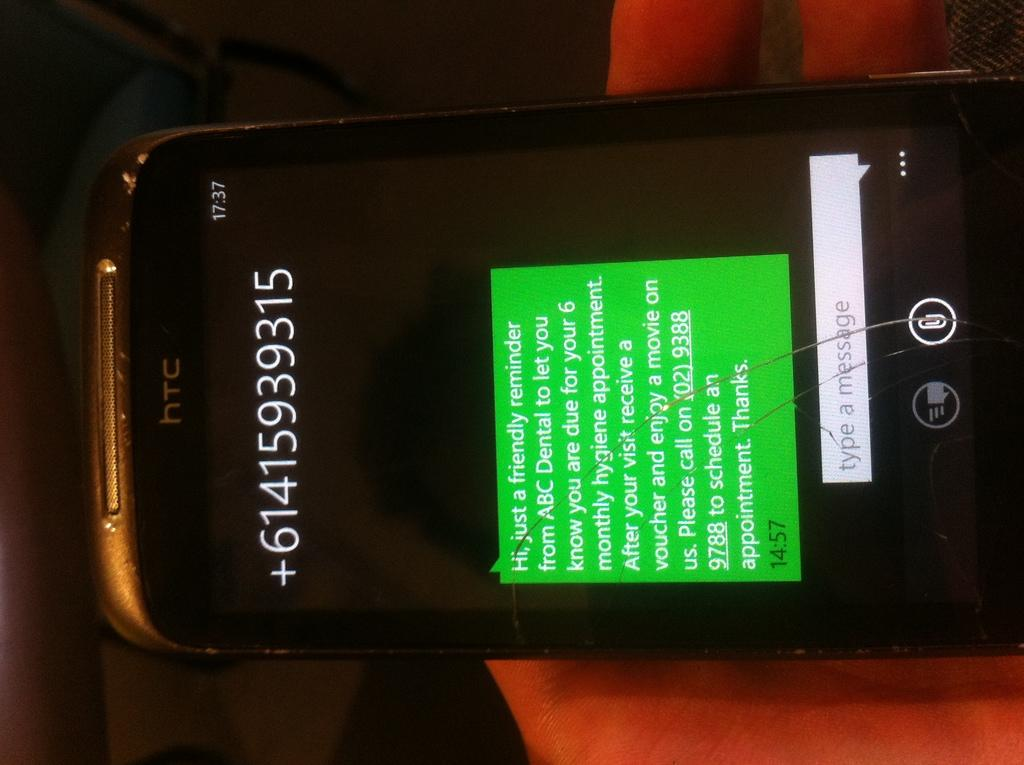<image>
Create a compact narrative representing the image presented. A phone screen displays a message that was sent at 14:57. 